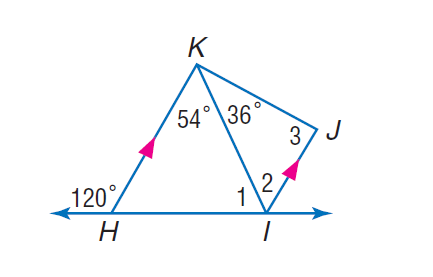Question: If K H is parallel to J I, find the measure of \angle 1.
Choices:
A. 23
B. 34
C. 66
D. 67
Answer with the letter. Answer: C Question: If K H is parallel to J I, find the measure of \angle 3.
Choices:
A. 36
B. 60
C. 90
D. 120
Answer with the letter. Answer: C Question: If K H is parallel to J I, find the measure of \angle 2.
Choices:
A. 36
B. 54
C. 56
D. 67
Answer with the letter. Answer: B 